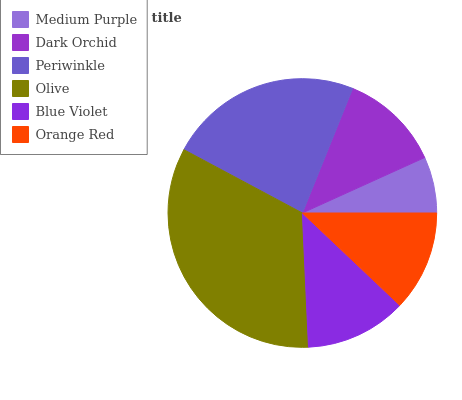Is Medium Purple the minimum?
Answer yes or no. Yes. Is Olive the maximum?
Answer yes or no. Yes. Is Dark Orchid the minimum?
Answer yes or no. No. Is Dark Orchid the maximum?
Answer yes or no. No. Is Dark Orchid greater than Medium Purple?
Answer yes or no. Yes. Is Medium Purple less than Dark Orchid?
Answer yes or no. Yes. Is Medium Purple greater than Dark Orchid?
Answer yes or no. No. Is Dark Orchid less than Medium Purple?
Answer yes or no. No. Is Blue Violet the high median?
Answer yes or no. Yes. Is Dark Orchid the low median?
Answer yes or no. Yes. Is Periwinkle the high median?
Answer yes or no. No. Is Orange Red the low median?
Answer yes or no. No. 